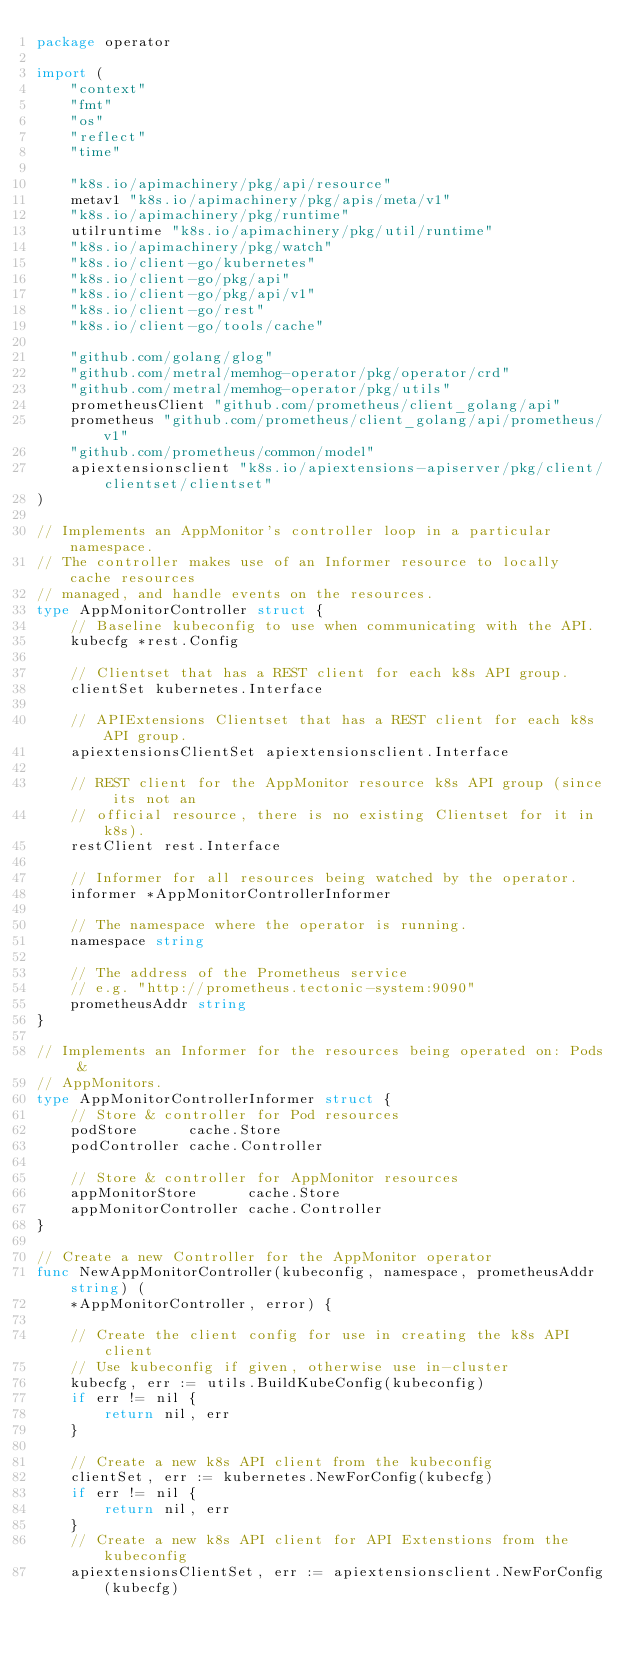<code> <loc_0><loc_0><loc_500><loc_500><_Go_>package operator

import (
	"context"
	"fmt"
	"os"
	"reflect"
	"time"

	"k8s.io/apimachinery/pkg/api/resource"
	metav1 "k8s.io/apimachinery/pkg/apis/meta/v1"
	"k8s.io/apimachinery/pkg/runtime"
	utilruntime "k8s.io/apimachinery/pkg/util/runtime"
	"k8s.io/apimachinery/pkg/watch"
	"k8s.io/client-go/kubernetes"
	"k8s.io/client-go/pkg/api"
	"k8s.io/client-go/pkg/api/v1"
	"k8s.io/client-go/rest"
	"k8s.io/client-go/tools/cache"

	"github.com/golang/glog"
	"github.com/metral/memhog-operator/pkg/operator/crd"
	"github.com/metral/memhog-operator/pkg/utils"
	prometheusClient "github.com/prometheus/client_golang/api"
	prometheus "github.com/prometheus/client_golang/api/prometheus/v1"
	"github.com/prometheus/common/model"
	apiextensionsclient "k8s.io/apiextensions-apiserver/pkg/client/clientset/clientset"
)

// Implements an AppMonitor's controller loop in a particular namespace.
// The controller makes use of an Informer resource to locally cache resources
// managed, and handle events on the resources.
type AppMonitorController struct {
	// Baseline kubeconfig to use when communicating with the API.
	kubecfg *rest.Config

	// Clientset that has a REST client for each k8s API group.
	clientSet kubernetes.Interface

	// APIExtensions Clientset that has a REST client for each k8s API group.
	apiextensionsClientSet apiextensionsclient.Interface

	// REST client for the AppMonitor resource k8s API group (since its not an
	// official resource, there is no existing Clientset for it in k8s).
	restClient rest.Interface

	// Informer for all resources being watched by the operator.
	informer *AppMonitorControllerInformer

	// The namespace where the operator is running.
	namespace string

	// The address of the Prometheus service
	// e.g. "http://prometheus.tectonic-system:9090"
	prometheusAddr string
}

// Implements an Informer for the resources being operated on: Pods &
// AppMonitors.
type AppMonitorControllerInformer struct {
	// Store & controller for Pod resources
	podStore      cache.Store
	podController cache.Controller

	// Store & controller for AppMonitor resources
	appMonitorStore      cache.Store
	appMonitorController cache.Controller
}

// Create a new Controller for the AppMonitor operator
func NewAppMonitorController(kubeconfig, namespace, prometheusAddr string) (
	*AppMonitorController, error) {

	// Create the client config for use in creating the k8s API client
	// Use kubeconfig if given, otherwise use in-cluster
	kubecfg, err := utils.BuildKubeConfig(kubeconfig)
	if err != nil {
		return nil, err
	}

	// Create a new k8s API client from the kubeconfig
	clientSet, err := kubernetes.NewForConfig(kubecfg)
	if err != nil {
		return nil, err
	}
	// Create a new k8s API client for API Extenstions from the kubeconfig
	apiextensionsClientSet, err := apiextensionsclient.NewForConfig(kubecfg)</code> 